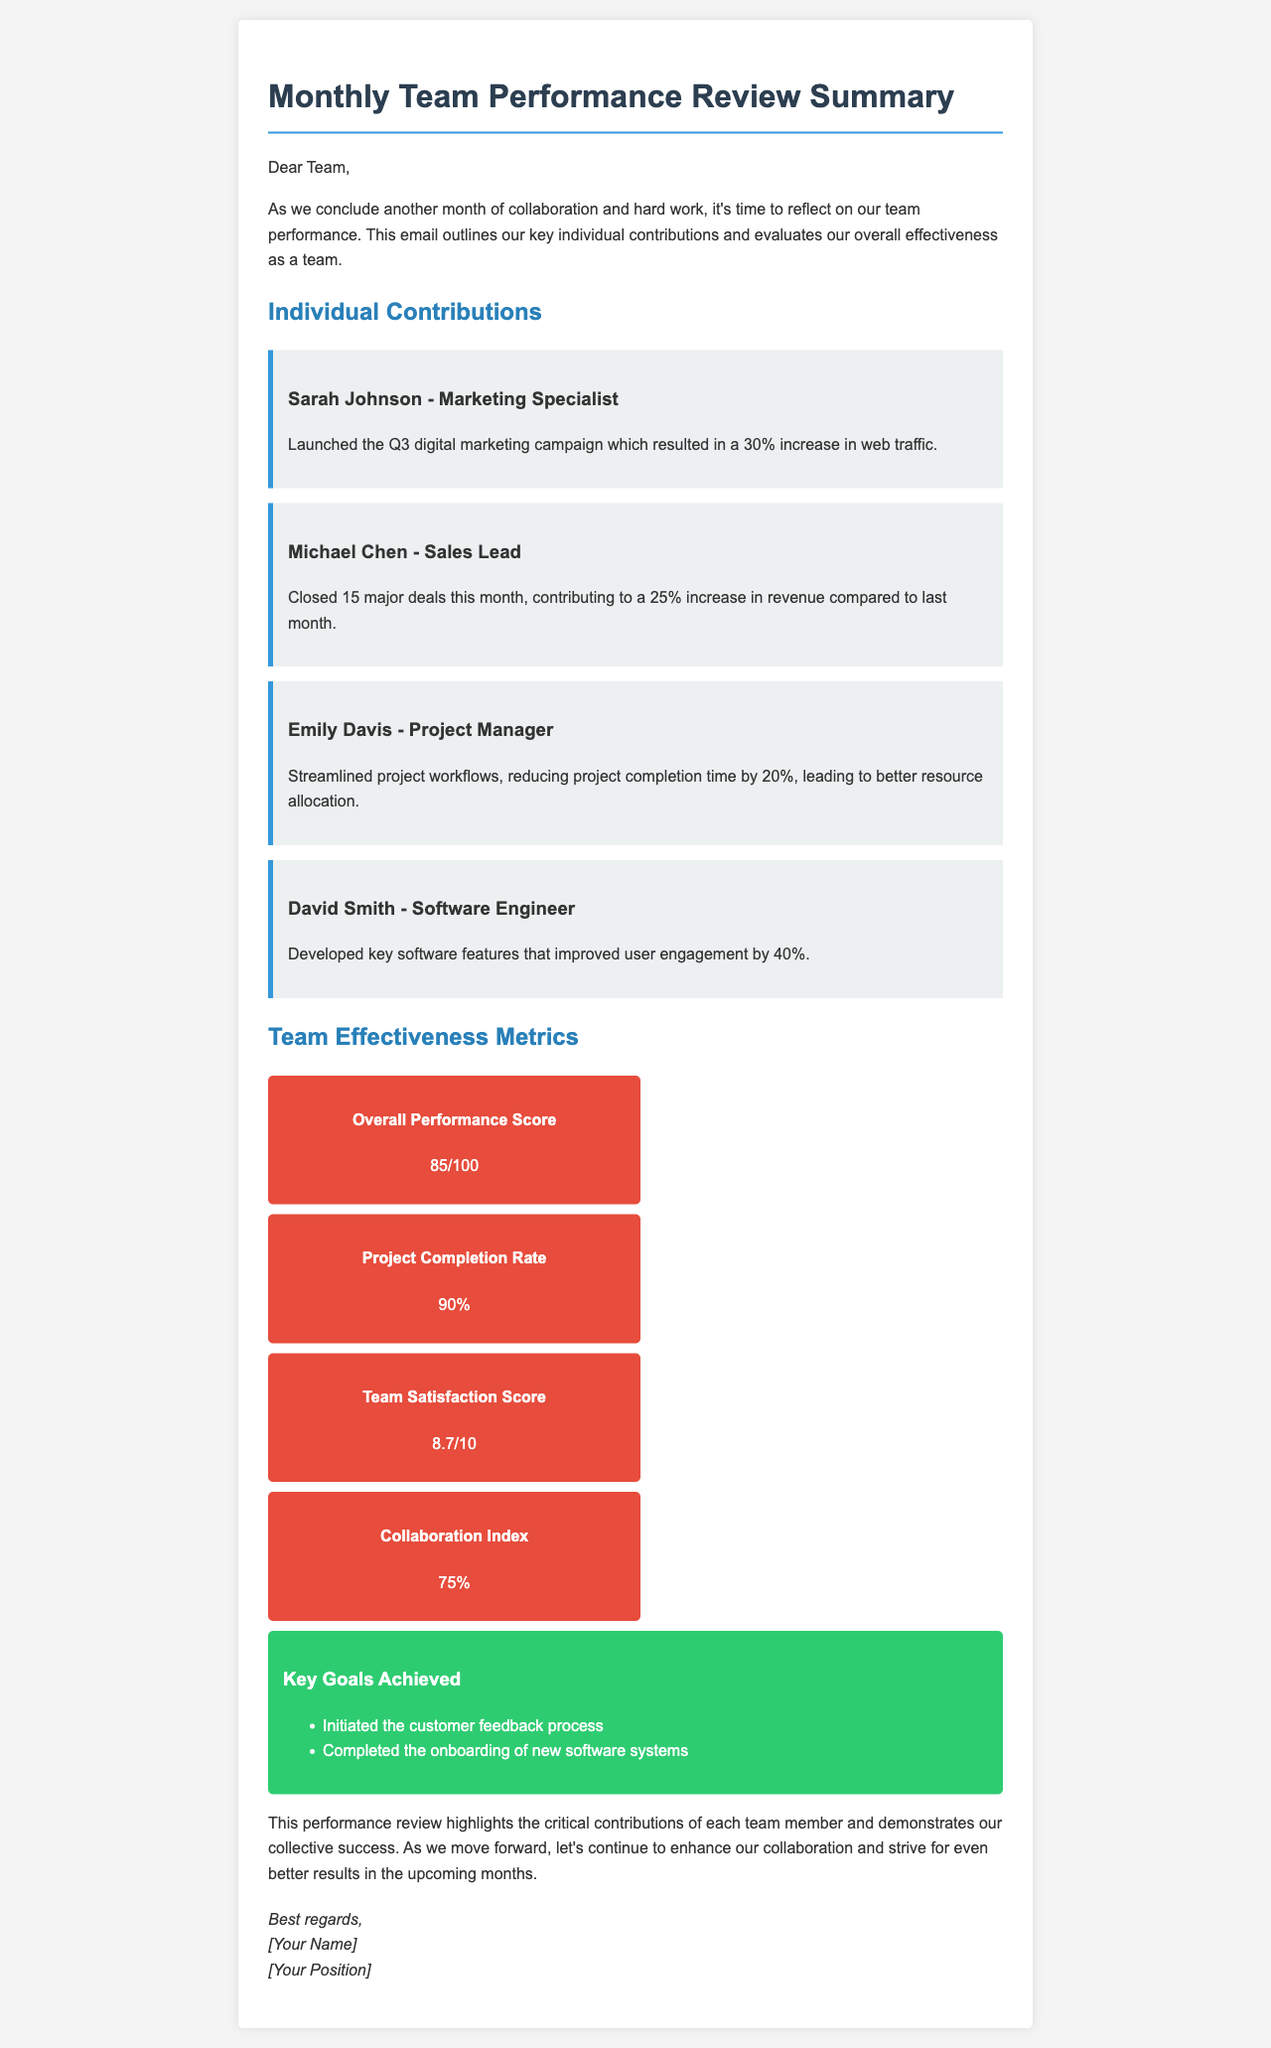What is Sarah Johnson's role? Sarah Johnson is identified as the Marketing Specialist in the document.
Answer: Marketing Specialist How much did web traffic increase after the Q3 digital marketing campaign? The document states that the digital marketing campaign led to a 30% increase in web traffic.
Answer: 30% What was Michael Chen's contribution to revenue increase? The document notes that Michael Chen closed 15 major deals, contributing to a 25% increase in revenue.
Answer: 25% What is the team's overall performance score? The document provides the overall performance score as 85 out of 100.
Answer: 85/100 What is the project completion rate? The project completion rate mentioned in the document is 90%.
Answer: 90% Which goal involved onboarding new software systems? The document lists "Completed the onboarding of new software systems" as one of the key goals achieved.
Answer: Completed the onboarding of new software systems What is the Team Satisfaction Score? According to the document, the Team Satisfaction Score is 8.7 out of 10.
Answer: 8.7/10 What percentage reflects the Collaboration Index? The document states that the Collaboration Index is 75%.
Answer: 75% Who is the Project Manager mentioned in the contributions? The document identifies Emily Davis as the Project Manager.
Answer: Emily Davis 